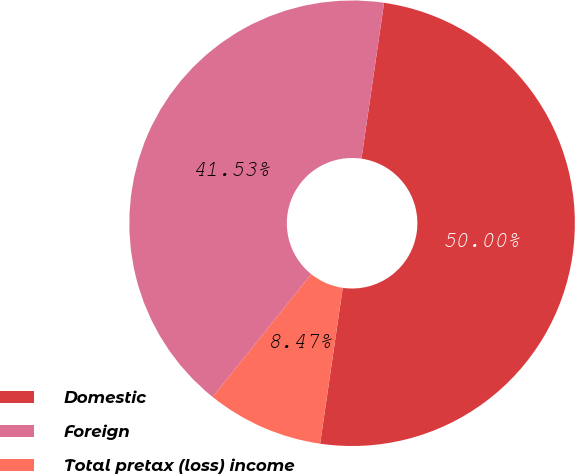Convert chart to OTSL. <chart><loc_0><loc_0><loc_500><loc_500><pie_chart><fcel>Domestic<fcel>Foreign<fcel>Total pretax (loss) income<nl><fcel>50.0%<fcel>41.53%<fcel>8.47%<nl></chart> 